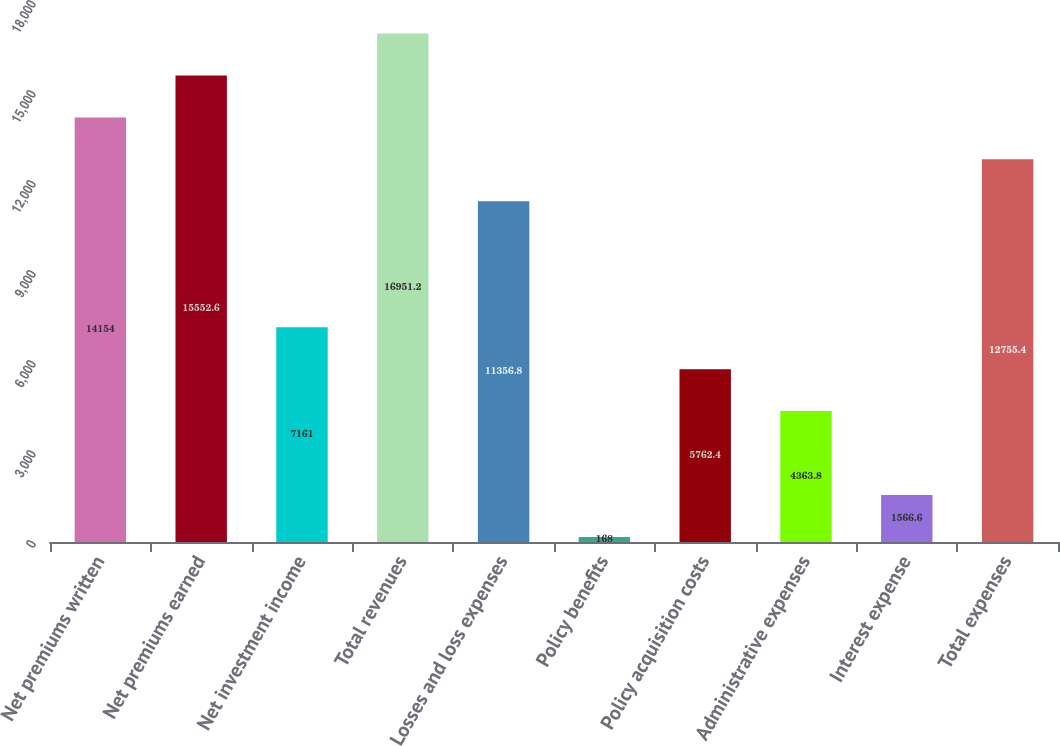Convert chart to OTSL. <chart><loc_0><loc_0><loc_500><loc_500><bar_chart><fcel>Net premiums written<fcel>Net premiums earned<fcel>Net investment income<fcel>Total revenues<fcel>Losses and loss expenses<fcel>Policy benefits<fcel>Policy acquisition costs<fcel>Administrative expenses<fcel>Interest expense<fcel>Total expenses<nl><fcel>14154<fcel>15552.6<fcel>7161<fcel>16951.2<fcel>11356.8<fcel>168<fcel>5762.4<fcel>4363.8<fcel>1566.6<fcel>12755.4<nl></chart> 